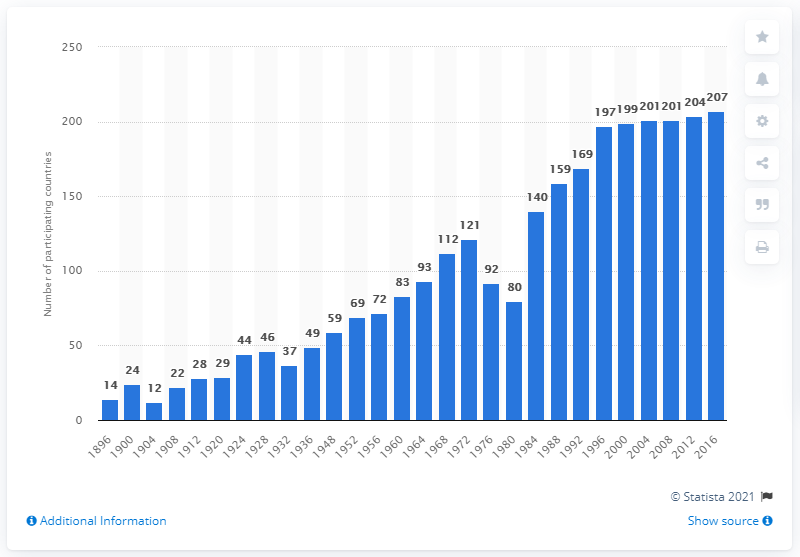Give some essential details in this illustration. In 2016, a total of 207 countries participated in the Summer Olympics held in Rio de Janeiro, marking a significant milestone for the international sporting event. 